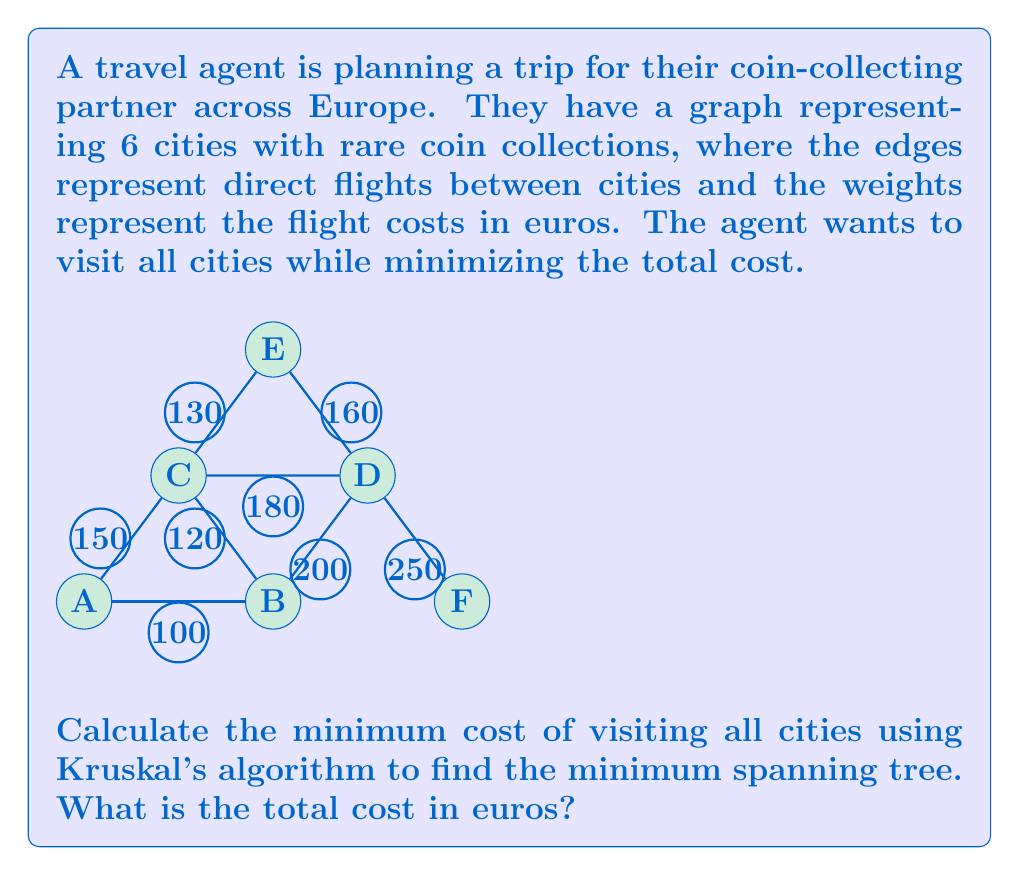Teach me how to tackle this problem. To solve this problem, we'll use Kruskal's algorithm to find the minimum spanning tree (MST) of the given graph. The steps are as follows:

1. Sort all edges by weight (cost) in ascending order:
   120 (B-C), 130 (C-E), 100 (A-B), 150 (A-C), 160 (D-E), 180 (C-D), 200 (B-D), 250 (D-F)

2. Initialize an empty set for the MST.

3. Iterate through the sorted edges:
   a) 120 (B-C): Add to MST
   b) 130 (C-E): Add to MST
   c) 100 (A-B): Add to MST
   d) 150 (A-C): Skip (creates a cycle)
   e) 160 (D-E): Add to MST
   f) 180 (C-D): Skip (creates a cycle)
   g) 200 (B-D): Skip (creates a cycle)
   h) 250 (D-F): Add to MST

4. The MST now contains 5 edges, connecting all 6 vertices:
   B-C (120), C-E (130), A-B (100), D-E (160), D-F (250)

5. Calculate the total cost by summing the weights of the edges in the MST:
   $$\text{Total cost} = 120 + 130 + 100 + 160 + 250 = 760\text{ euros}$$

Therefore, the minimum cost to visit all cities is 760 euros.
Answer: 760 euros 